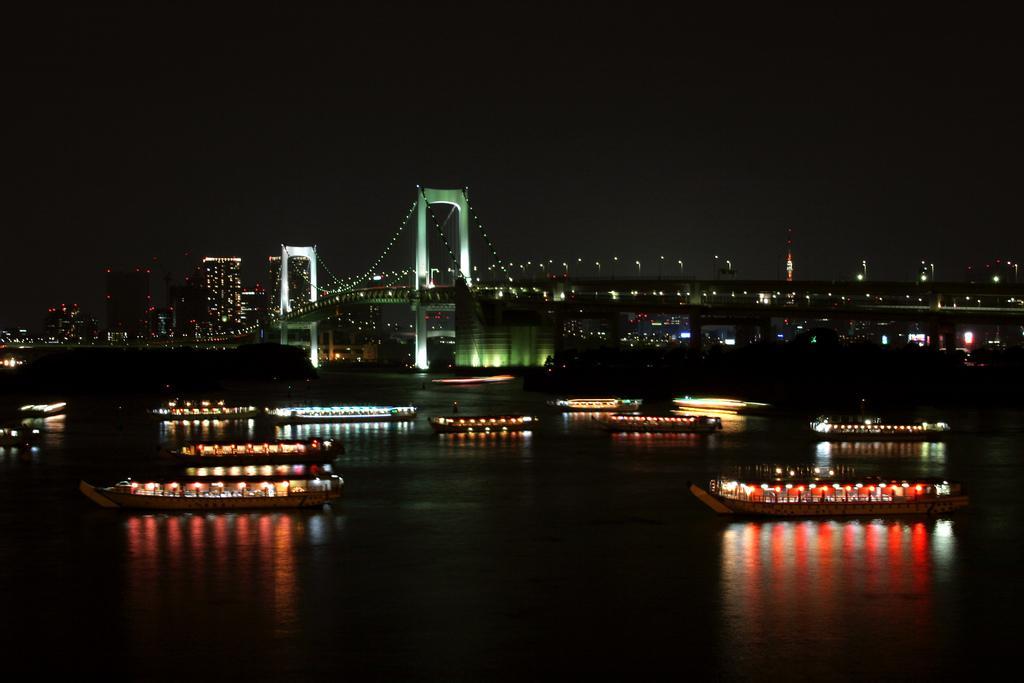Could you give a brief overview of what you see in this image? In this image there is water and we can see boats on the water. In the background there is a bridge, buildings, poles, lights and sky. 